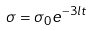<formula> <loc_0><loc_0><loc_500><loc_500>\sigma = \sigma _ { 0 } e ^ { - 3 l t }</formula> 